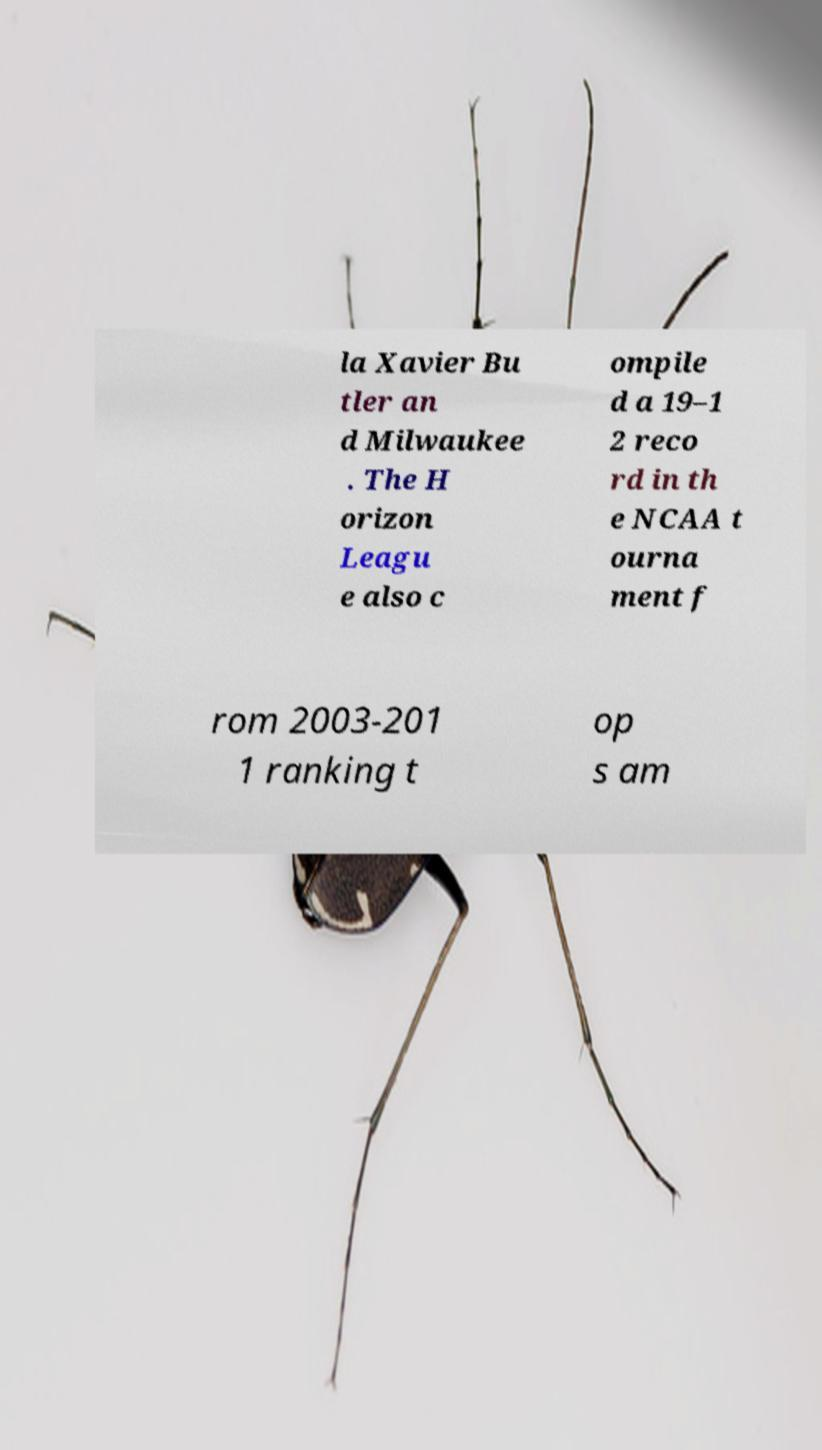Can you accurately transcribe the text from the provided image for me? la Xavier Bu tler an d Milwaukee . The H orizon Leagu e also c ompile d a 19–1 2 reco rd in th e NCAA t ourna ment f rom 2003-201 1 ranking t op s am 